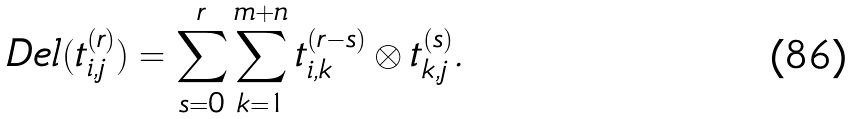Convert formula to latex. <formula><loc_0><loc_0><loc_500><loc_500>\ D e l ( t _ { i , j } ^ { ( r ) } ) = \sum _ { s = 0 } ^ { r } \sum _ { k = 1 } ^ { m + n } t _ { i , k } ^ { ( r - s ) } \otimes t _ { k , j } ^ { ( s ) } .</formula> 